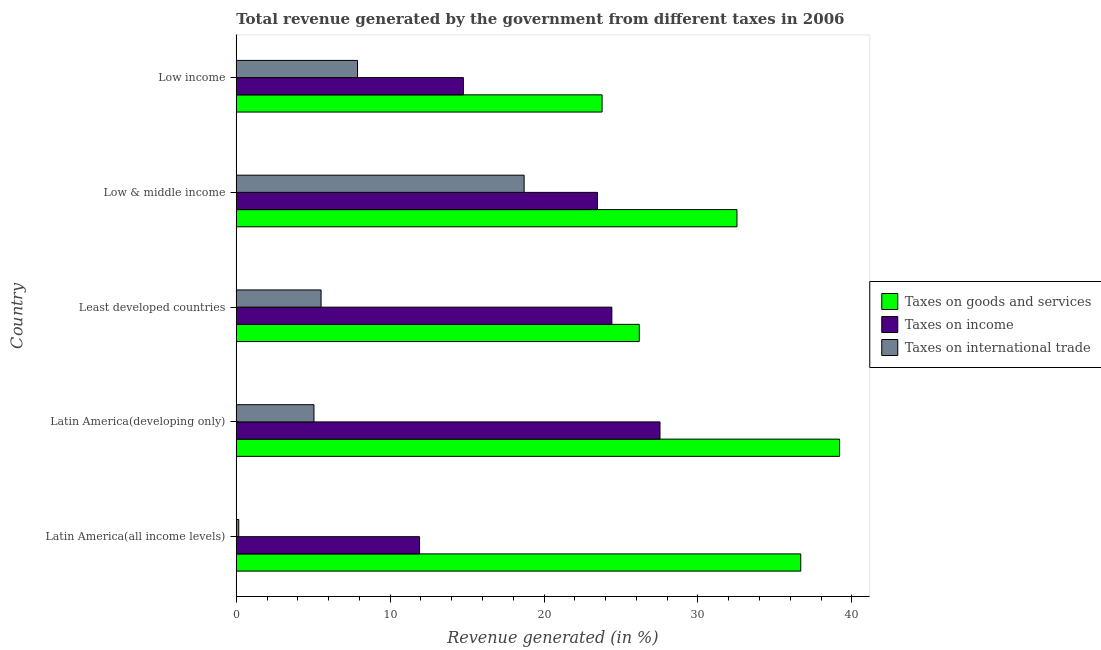Are the number of bars per tick equal to the number of legend labels?
Your answer should be very brief. Yes. In how many cases, is the number of bars for a given country not equal to the number of legend labels?
Offer a terse response. 0. What is the percentage of revenue generated by tax on international trade in Least developed countries?
Give a very brief answer. 5.51. Across all countries, what is the maximum percentage of revenue generated by taxes on goods and services?
Provide a succinct answer. 39.2. Across all countries, what is the minimum percentage of revenue generated by taxes on income?
Keep it short and to the point. 11.91. In which country was the percentage of revenue generated by taxes on income maximum?
Give a very brief answer. Latin America(developing only). What is the total percentage of revenue generated by taxes on income in the graph?
Offer a terse response. 102.09. What is the difference between the percentage of revenue generated by taxes on goods and services in Latin America(all income levels) and that in Latin America(developing only)?
Your response must be concise. -2.52. What is the difference between the percentage of revenue generated by tax on international trade in Least developed countries and the percentage of revenue generated by taxes on goods and services in Latin America(developing only)?
Your answer should be compact. -33.69. What is the average percentage of revenue generated by tax on international trade per country?
Offer a terse response. 7.46. What is the difference between the percentage of revenue generated by taxes on income and percentage of revenue generated by taxes on goods and services in Latin America(all income levels)?
Your response must be concise. -24.77. What is the ratio of the percentage of revenue generated by taxes on income in Latin America(all income levels) to that in Low income?
Provide a short and direct response. 0.81. Is the percentage of revenue generated by taxes on income in Least developed countries less than that in Low & middle income?
Offer a very short reply. No. What is the difference between the highest and the second highest percentage of revenue generated by taxes on goods and services?
Your response must be concise. 2.52. What is the difference between the highest and the lowest percentage of revenue generated by taxes on income?
Keep it short and to the point. 15.62. In how many countries, is the percentage of revenue generated by taxes on goods and services greater than the average percentage of revenue generated by taxes on goods and services taken over all countries?
Ensure brevity in your answer.  3. What does the 1st bar from the top in Latin America(developing only) represents?
Provide a succinct answer. Taxes on international trade. What does the 1st bar from the bottom in Low & middle income represents?
Your answer should be compact. Taxes on goods and services. How many bars are there?
Your answer should be very brief. 15. Are all the bars in the graph horizontal?
Your response must be concise. Yes. What is the difference between two consecutive major ticks on the X-axis?
Your answer should be compact. 10. Does the graph contain grids?
Give a very brief answer. No. How are the legend labels stacked?
Provide a short and direct response. Vertical. What is the title of the graph?
Ensure brevity in your answer.  Total revenue generated by the government from different taxes in 2006. What is the label or title of the X-axis?
Your response must be concise. Revenue generated (in %). What is the label or title of the Y-axis?
Offer a very short reply. Country. What is the Revenue generated (in %) of Taxes on goods and services in Latin America(all income levels)?
Your answer should be very brief. 36.68. What is the Revenue generated (in %) in Taxes on income in Latin America(all income levels)?
Offer a very short reply. 11.91. What is the Revenue generated (in %) in Taxes on international trade in Latin America(all income levels)?
Your answer should be very brief. 0.16. What is the Revenue generated (in %) in Taxes on goods and services in Latin America(developing only)?
Your answer should be very brief. 39.2. What is the Revenue generated (in %) of Taxes on income in Latin America(developing only)?
Your answer should be very brief. 27.53. What is the Revenue generated (in %) of Taxes on international trade in Latin America(developing only)?
Your answer should be compact. 5.05. What is the Revenue generated (in %) in Taxes on goods and services in Least developed countries?
Provide a succinct answer. 26.19. What is the Revenue generated (in %) of Taxes on income in Least developed countries?
Provide a succinct answer. 24.41. What is the Revenue generated (in %) of Taxes on international trade in Least developed countries?
Your answer should be very brief. 5.51. What is the Revenue generated (in %) of Taxes on goods and services in Low & middle income?
Make the answer very short. 32.54. What is the Revenue generated (in %) of Taxes on income in Low & middle income?
Your answer should be compact. 23.47. What is the Revenue generated (in %) of Taxes on international trade in Low & middle income?
Offer a terse response. 18.71. What is the Revenue generated (in %) of Taxes on goods and services in Low income?
Your answer should be very brief. 23.77. What is the Revenue generated (in %) in Taxes on income in Low income?
Offer a very short reply. 14.76. What is the Revenue generated (in %) in Taxes on international trade in Low income?
Offer a terse response. 7.88. Across all countries, what is the maximum Revenue generated (in %) in Taxes on goods and services?
Offer a terse response. 39.2. Across all countries, what is the maximum Revenue generated (in %) of Taxes on income?
Give a very brief answer. 27.53. Across all countries, what is the maximum Revenue generated (in %) of Taxes on international trade?
Make the answer very short. 18.71. Across all countries, what is the minimum Revenue generated (in %) in Taxes on goods and services?
Offer a very short reply. 23.77. Across all countries, what is the minimum Revenue generated (in %) in Taxes on income?
Provide a succinct answer. 11.91. Across all countries, what is the minimum Revenue generated (in %) in Taxes on international trade?
Your answer should be very brief. 0.16. What is the total Revenue generated (in %) in Taxes on goods and services in the graph?
Ensure brevity in your answer.  158.38. What is the total Revenue generated (in %) in Taxes on income in the graph?
Offer a very short reply. 102.09. What is the total Revenue generated (in %) of Taxes on international trade in the graph?
Your answer should be compact. 37.31. What is the difference between the Revenue generated (in %) of Taxes on goods and services in Latin America(all income levels) and that in Latin America(developing only)?
Give a very brief answer. -2.52. What is the difference between the Revenue generated (in %) in Taxes on income in Latin America(all income levels) and that in Latin America(developing only)?
Your answer should be compact. -15.62. What is the difference between the Revenue generated (in %) in Taxes on international trade in Latin America(all income levels) and that in Latin America(developing only)?
Your response must be concise. -4.89. What is the difference between the Revenue generated (in %) in Taxes on goods and services in Latin America(all income levels) and that in Least developed countries?
Ensure brevity in your answer.  10.49. What is the difference between the Revenue generated (in %) in Taxes on income in Latin America(all income levels) and that in Least developed countries?
Ensure brevity in your answer.  -12.49. What is the difference between the Revenue generated (in %) of Taxes on international trade in Latin America(all income levels) and that in Least developed countries?
Make the answer very short. -5.35. What is the difference between the Revenue generated (in %) in Taxes on goods and services in Latin America(all income levels) and that in Low & middle income?
Make the answer very short. 4.15. What is the difference between the Revenue generated (in %) in Taxes on income in Latin America(all income levels) and that in Low & middle income?
Your response must be concise. -11.56. What is the difference between the Revenue generated (in %) in Taxes on international trade in Latin America(all income levels) and that in Low & middle income?
Offer a terse response. -18.54. What is the difference between the Revenue generated (in %) of Taxes on goods and services in Latin America(all income levels) and that in Low income?
Your response must be concise. 12.91. What is the difference between the Revenue generated (in %) of Taxes on income in Latin America(all income levels) and that in Low income?
Make the answer very short. -2.85. What is the difference between the Revenue generated (in %) in Taxes on international trade in Latin America(all income levels) and that in Low income?
Your answer should be very brief. -7.72. What is the difference between the Revenue generated (in %) of Taxes on goods and services in Latin America(developing only) and that in Least developed countries?
Provide a short and direct response. 13.02. What is the difference between the Revenue generated (in %) of Taxes on income in Latin America(developing only) and that in Least developed countries?
Give a very brief answer. 3.13. What is the difference between the Revenue generated (in %) in Taxes on international trade in Latin America(developing only) and that in Least developed countries?
Your answer should be compact. -0.46. What is the difference between the Revenue generated (in %) of Taxes on goods and services in Latin America(developing only) and that in Low & middle income?
Give a very brief answer. 6.67. What is the difference between the Revenue generated (in %) of Taxes on income in Latin America(developing only) and that in Low & middle income?
Offer a very short reply. 4.06. What is the difference between the Revenue generated (in %) of Taxes on international trade in Latin America(developing only) and that in Low & middle income?
Keep it short and to the point. -13.66. What is the difference between the Revenue generated (in %) in Taxes on goods and services in Latin America(developing only) and that in Low income?
Your response must be concise. 15.43. What is the difference between the Revenue generated (in %) in Taxes on income in Latin America(developing only) and that in Low income?
Offer a very short reply. 12.78. What is the difference between the Revenue generated (in %) in Taxes on international trade in Latin America(developing only) and that in Low income?
Provide a succinct answer. -2.83. What is the difference between the Revenue generated (in %) of Taxes on goods and services in Least developed countries and that in Low & middle income?
Give a very brief answer. -6.35. What is the difference between the Revenue generated (in %) in Taxes on income in Least developed countries and that in Low & middle income?
Your answer should be compact. 0.93. What is the difference between the Revenue generated (in %) of Taxes on international trade in Least developed countries and that in Low & middle income?
Your answer should be very brief. -13.19. What is the difference between the Revenue generated (in %) of Taxes on goods and services in Least developed countries and that in Low income?
Provide a succinct answer. 2.42. What is the difference between the Revenue generated (in %) of Taxes on income in Least developed countries and that in Low income?
Provide a short and direct response. 9.65. What is the difference between the Revenue generated (in %) of Taxes on international trade in Least developed countries and that in Low income?
Offer a terse response. -2.37. What is the difference between the Revenue generated (in %) of Taxes on goods and services in Low & middle income and that in Low income?
Provide a short and direct response. 8.76. What is the difference between the Revenue generated (in %) in Taxes on income in Low & middle income and that in Low income?
Offer a very short reply. 8.72. What is the difference between the Revenue generated (in %) of Taxes on international trade in Low & middle income and that in Low income?
Your answer should be compact. 10.82. What is the difference between the Revenue generated (in %) of Taxes on goods and services in Latin America(all income levels) and the Revenue generated (in %) of Taxes on income in Latin America(developing only)?
Ensure brevity in your answer.  9.15. What is the difference between the Revenue generated (in %) of Taxes on goods and services in Latin America(all income levels) and the Revenue generated (in %) of Taxes on international trade in Latin America(developing only)?
Offer a very short reply. 31.63. What is the difference between the Revenue generated (in %) of Taxes on income in Latin America(all income levels) and the Revenue generated (in %) of Taxes on international trade in Latin America(developing only)?
Give a very brief answer. 6.86. What is the difference between the Revenue generated (in %) in Taxes on goods and services in Latin America(all income levels) and the Revenue generated (in %) in Taxes on income in Least developed countries?
Your answer should be very brief. 12.27. What is the difference between the Revenue generated (in %) of Taxes on goods and services in Latin America(all income levels) and the Revenue generated (in %) of Taxes on international trade in Least developed countries?
Your answer should be very brief. 31.17. What is the difference between the Revenue generated (in %) in Taxes on income in Latin America(all income levels) and the Revenue generated (in %) in Taxes on international trade in Least developed countries?
Offer a very short reply. 6.4. What is the difference between the Revenue generated (in %) of Taxes on goods and services in Latin America(all income levels) and the Revenue generated (in %) of Taxes on income in Low & middle income?
Your response must be concise. 13.21. What is the difference between the Revenue generated (in %) in Taxes on goods and services in Latin America(all income levels) and the Revenue generated (in %) in Taxes on international trade in Low & middle income?
Ensure brevity in your answer.  17.97. What is the difference between the Revenue generated (in %) in Taxes on income in Latin America(all income levels) and the Revenue generated (in %) in Taxes on international trade in Low & middle income?
Offer a very short reply. -6.79. What is the difference between the Revenue generated (in %) in Taxes on goods and services in Latin America(all income levels) and the Revenue generated (in %) in Taxes on income in Low income?
Provide a short and direct response. 21.92. What is the difference between the Revenue generated (in %) of Taxes on goods and services in Latin America(all income levels) and the Revenue generated (in %) of Taxes on international trade in Low income?
Offer a terse response. 28.8. What is the difference between the Revenue generated (in %) of Taxes on income in Latin America(all income levels) and the Revenue generated (in %) of Taxes on international trade in Low income?
Keep it short and to the point. 4.03. What is the difference between the Revenue generated (in %) in Taxes on goods and services in Latin America(developing only) and the Revenue generated (in %) in Taxes on income in Least developed countries?
Give a very brief answer. 14.8. What is the difference between the Revenue generated (in %) of Taxes on goods and services in Latin America(developing only) and the Revenue generated (in %) of Taxes on international trade in Least developed countries?
Your answer should be very brief. 33.69. What is the difference between the Revenue generated (in %) of Taxes on income in Latin America(developing only) and the Revenue generated (in %) of Taxes on international trade in Least developed countries?
Provide a succinct answer. 22.02. What is the difference between the Revenue generated (in %) in Taxes on goods and services in Latin America(developing only) and the Revenue generated (in %) in Taxes on income in Low & middle income?
Your answer should be compact. 15.73. What is the difference between the Revenue generated (in %) of Taxes on goods and services in Latin America(developing only) and the Revenue generated (in %) of Taxes on international trade in Low & middle income?
Ensure brevity in your answer.  20.5. What is the difference between the Revenue generated (in %) in Taxes on income in Latin America(developing only) and the Revenue generated (in %) in Taxes on international trade in Low & middle income?
Give a very brief answer. 8.83. What is the difference between the Revenue generated (in %) in Taxes on goods and services in Latin America(developing only) and the Revenue generated (in %) in Taxes on income in Low income?
Make the answer very short. 24.45. What is the difference between the Revenue generated (in %) in Taxes on goods and services in Latin America(developing only) and the Revenue generated (in %) in Taxes on international trade in Low income?
Ensure brevity in your answer.  31.32. What is the difference between the Revenue generated (in %) of Taxes on income in Latin America(developing only) and the Revenue generated (in %) of Taxes on international trade in Low income?
Ensure brevity in your answer.  19.65. What is the difference between the Revenue generated (in %) of Taxes on goods and services in Least developed countries and the Revenue generated (in %) of Taxes on income in Low & middle income?
Offer a very short reply. 2.71. What is the difference between the Revenue generated (in %) in Taxes on goods and services in Least developed countries and the Revenue generated (in %) in Taxes on international trade in Low & middle income?
Ensure brevity in your answer.  7.48. What is the difference between the Revenue generated (in %) of Taxes on income in Least developed countries and the Revenue generated (in %) of Taxes on international trade in Low & middle income?
Provide a short and direct response. 5.7. What is the difference between the Revenue generated (in %) in Taxes on goods and services in Least developed countries and the Revenue generated (in %) in Taxes on income in Low income?
Ensure brevity in your answer.  11.43. What is the difference between the Revenue generated (in %) of Taxes on goods and services in Least developed countries and the Revenue generated (in %) of Taxes on international trade in Low income?
Provide a short and direct response. 18.31. What is the difference between the Revenue generated (in %) of Taxes on income in Least developed countries and the Revenue generated (in %) of Taxes on international trade in Low income?
Ensure brevity in your answer.  16.53. What is the difference between the Revenue generated (in %) in Taxes on goods and services in Low & middle income and the Revenue generated (in %) in Taxes on income in Low income?
Offer a very short reply. 17.78. What is the difference between the Revenue generated (in %) of Taxes on goods and services in Low & middle income and the Revenue generated (in %) of Taxes on international trade in Low income?
Your answer should be very brief. 24.65. What is the difference between the Revenue generated (in %) of Taxes on income in Low & middle income and the Revenue generated (in %) of Taxes on international trade in Low income?
Make the answer very short. 15.59. What is the average Revenue generated (in %) in Taxes on goods and services per country?
Provide a succinct answer. 31.68. What is the average Revenue generated (in %) of Taxes on income per country?
Ensure brevity in your answer.  20.42. What is the average Revenue generated (in %) in Taxes on international trade per country?
Your response must be concise. 7.46. What is the difference between the Revenue generated (in %) in Taxes on goods and services and Revenue generated (in %) in Taxes on income in Latin America(all income levels)?
Provide a short and direct response. 24.77. What is the difference between the Revenue generated (in %) of Taxes on goods and services and Revenue generated (in %) of Taxes on international trade in Latin America(all income levels)?
Make the answer very short. 36.52. What is the difference between the Revenue generated (in %) of Taxes on income and Revenue generated (in %) of Taxes on international trade in Latin America(all income levels)?
Your response must be concise. 11.75. What is the difference between the Revenue generated (in %) of Taxes on goods and services and Revenue generated (in %) of Taxes on income in Latin America(developing only)?
Give a very brief answer. 11.67. What is the difference between the Revenue generated (in %) of Taxes on goods and services and Revenue generated (in %) of Taxes on international trade in Latin America(developing only)?
Your response must be concise. 34.15. What is the difference between the Revenue generated (in %) of Taxes on income and Revenue generated (in %) of Taxes on international trade in Latin America(developing only)?
Make the answer very short. 22.48. What is the difference between the Revenue generated (in %) in Taxes on goods and services and Revenue generated (in %) in Taxes on income in Least developed countries?
Ensure brevity in your answer.  1.78. What is the difference between the Revenue generated (in %) in Taxes on goods and services and Revenue generated (in %) in Taxes on international trade in Least developed countries?
Your response must be concise. 20.68. What is the difference between the Revenue generated (in %) of Taxes on income and Revenue generated (in %) of Taxes on international trade in Least developed countries?
Offer a terse response. 18.89. What is the difference between the Revenue generated (in %) in Taxes on goods and services and Revenue generated (in %) in Taxes on income in Low & middle income?
Keep it short and to the point. 9.06. What is the difference between the Revenue generated (in %) of Taxes on goods and services and Revenue generated (in %) of Taxes on international trade in Low & middle income?
Give a very brief answer. 13.83. What is the difference between the Revenue generated (in %) in Taxes on income and Revenue generated (in %) in Taxes on international trade in Low & middle income?
Ensure brevity in your answer.  4.77. What is the difference between the Revenue generated (in %) in Taxes on goods and services and Revenue generated (in %) in Taxes on income in Low income?
Offer a terse response. 9.01. What is the difference between the Revenue generated (in %) of Taxes on goods and services and Revenue generated (in %) of Taxes on international trade in Low income?
Make the answer very short. 15.89. What is the difference between the Revenue generated (in %) of Taxes on income and Revenue generated (in %) of Taxes on international trade in Low income?
Offer a very short reply. 6.88. What is the ratio of the Revenue generated (in %) in Taxes on goods and services in Latin America(all income levels) to that in Latin America(developing only)?
Make the answer very short. 0.94. What is the ratio of the Revenue generated (in %) in Taxes on income in Latin America(all income levels) to that in Latin America(developing only)?
Provide a succinct answer. 0.43. What is the ratio of the Revenue generated (in %) in Taxes on international trade in Latin America(all income levels) to that in Latin America(developing only)?
Offer a terse response. 0.03. What is the ratio of the Revenue generated (in %) in Taxes on goods and services in Latin America(all income levels) to that in Least developed countries?
Provide a short and direct response. 1.4. What is the ratio of the Revenue generated (in %) of Taxes on income in Latin America(all income levels) to that in Least developed countries?
Your answer should be compact. 0.49. What is the ratio of the Revenue generated (in %) of Taxes on international trade in Latin America(all income levels) to that in Least developed countries?
Your answer should be very brief. 0.03. What is the ratio of the Revenue generated (in %) in Taxes on goods and services in Latin America(all income levels) to that in Low & middle income?
Your answer should be very brief. 1.13. What is the ratio of the Revenue generated (in %) of Taxes on income in Latin America(all income levels) to that in Low & middle income?
Give a very brief answer. 0.51. What is the ratio of the Revenue generated (in %) in Taxes on international trade in Latin America(all income levels) to that in Low & middle income?
Offer a terse response. 0.01. What is the ratio of the Revenue generated (in %) in Taxes on goods and services in Latin America(all income levels) to that in Low income?
Ensure brevity in your answer.  1.54. What is the ratio of the Revenue generated (in %) of Taxes on income in Latin America(all income levels) to that in Low income?
Make the answer very short. 0.81. What is the ratio of the Revenue generated (in %) in Taxes on international trade in Latin America(all income levels) to that in Low income?
Your response must be concise. 0.02. What is the ratio of the Revenue generated (in %) in Taxes on goods and services in Latin America(developing only) to that in Least developed countries?
Offer a very short reply. 1.5. What is the ratio of the Revenue generated (in %) of Taxes on income in Latin America(developing only) to that in Least developed countries?
Keep it short and to the point. 1.13. What is the ratio of the Revenue generated (in %) in Taxes on international trade in Latin America(developing only) to that in Least developed countries?
Offer a very short reply. 0.92. What is the ratio of the Revenue generated (in %) in Taxes on goods and services in Latin America(developing only) to that in Low & middle income?
Provide a succinct answer. 1.21. What is the ratio of the Revenue generated (in %) in Taxes on income in Latin America(developing only) to that in Low & middle income?
Offer a very short reply. 1.17. What is the ratio of the Revenue generated (in %) in Taxes on international trade in Latin America(developing only) to that in Low & middle income?
Keep it short and to the point. 0.27. What is the ratio of the Revenue generated (in %) in Taxes on goods and services in Latin America(developing only) to that in Low income?
Your answer should be very brief. 1.65. What is the ratio of the Revenue generated (in %) in Taxes on income in Latin America(developing only) to that in Low income?
Your answer should be compact. 1.87. What is the ratio of the Revenue generated (in %) in Taxes on international trade in Latin America(developing only) to that in Low income?
Your response must be concise. 0.64. What is the ratio of the Revenue generated (in %) of Taxes on goods and services in Least developed countries to that in Low & middle income?
Offer a terse response. 0.8. What is the ratio of the Revenue generated (in %) of Taxes on income in Least developed countries to that in Low & middle income?
Offer a terse response. 1.04. What is the ratio of the Revenue generated (in %) in Taxes on international trade in Least developed countries to that in Low & middle income?
Your answer should be compact. 0.29. What is the ratio of the Revenue generated (in %) in Taxes on goods and services in Least developed countries to that in Low income?
Make the answer very short. 1.1. What is the ratio of the Revenue generated (in %) in Taxes on income in Least developed countries to that in Low income?
Provide a succinct answer. 1.65. What is the ratio of the Revenue generated (in %) in Taxes on international trade in Least developed countries to that in Low income?
Provide a short and direct response. 0.7. What is the ratio of the Revenue generated (in %) in Taxes on goods and services in Low & middle income to that in Low income?
Your answer should be compact. 1.37. What is the ratio of the Revenue generated (in %) in Taxes on income in Low & middle income to that in Low income?
Offer a very short reply. 1.59. What is the ratio of the Revenue generated (in %) in Taxes on international trade in Low & middle income to that in Low income?
Ensure brevity in your answer.  2.37. What is the difference between the highest and the second highest Revenue generated (in %) of Taxes on goods and services?
Ensure brevity in your answer.  2.52. What is the difference between the highest and the second highest Revenue generated (in %) of Taxes on income?
Keep it short and to the point. 3.13. What is the difference between the highest and the second highest Revenue generated (in %) in Taxes on international trade?
Offer a very short reply. 10.82. What is the difference between the highest and the lowest Revenue generated (in %) in Taxes on goods and services?
Provide a succinct answer. 15.43. What is the difference between the highest and the lowest Revenue generated (in %) of Taxes on income?
Offer a very short reply. 15.62. What is the difference between the highest and the lowest Revenue generated (in %) of Taxes on international trade?
Offer a terse response. 18.54. 